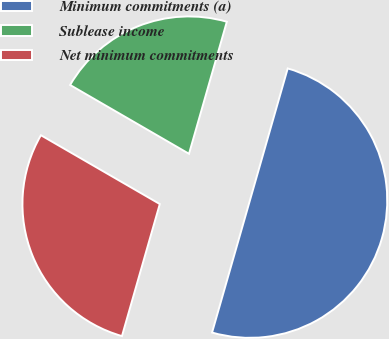Convert chart. <chart><loc_0><loc_0><loc_500><loc_500><pie_chart><fcel>Minimum commitments (a)<fcel>Sublease income<fcel>Net minimum commitments<nl><fcel>50.0%<fcel>21.09%<fcel>28.91%<nl></chart> 